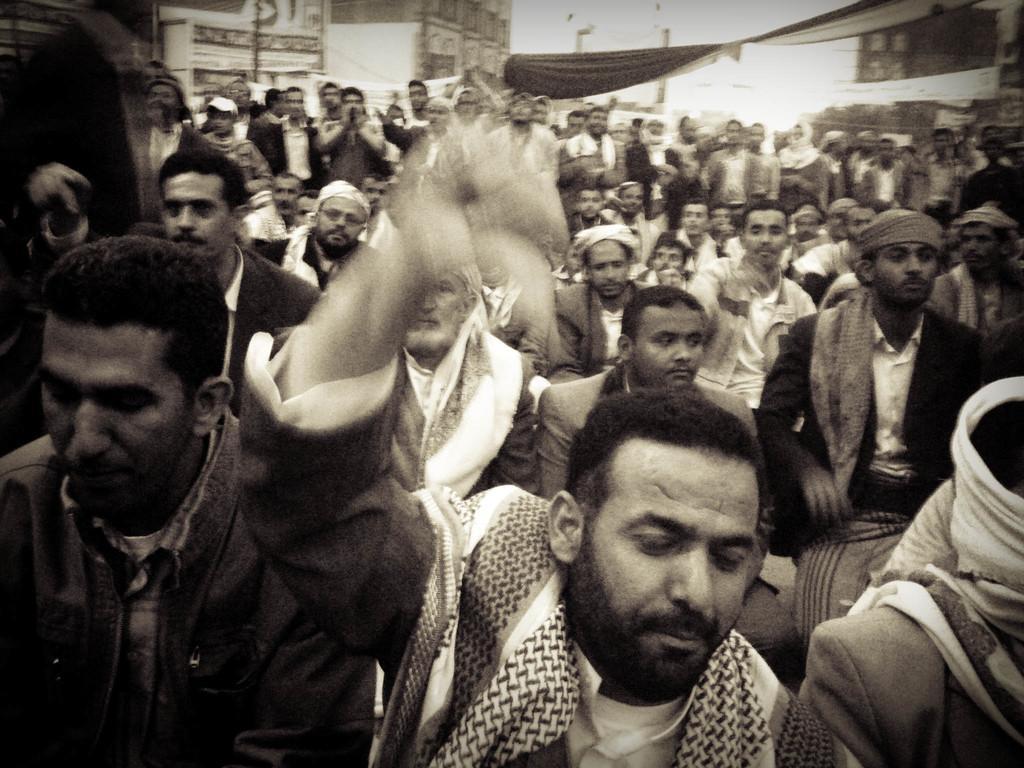In one or two sentences, can you explain what this image depicts? This is a black and white image. In this image we can see people. 